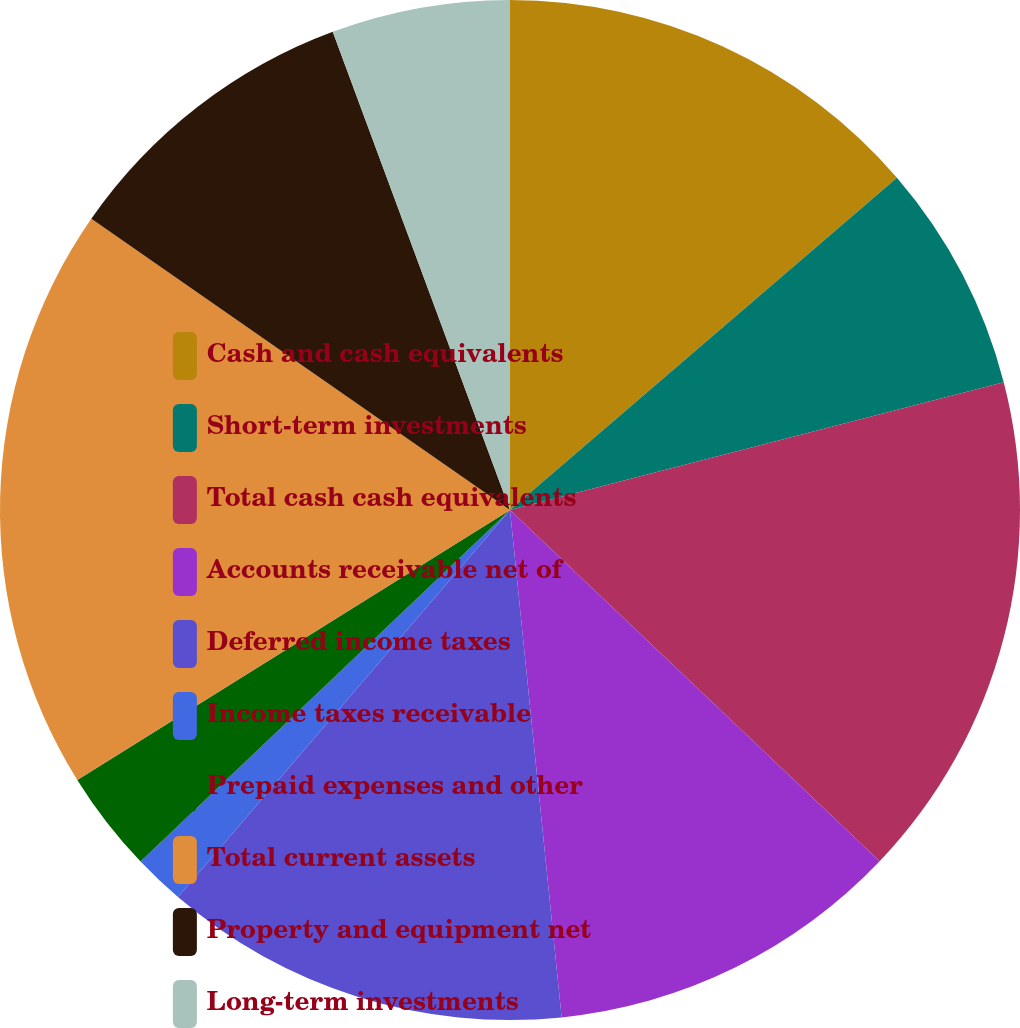<chart> <loc_0><loc_0><loc_500><loc_500><pie_chart><fcel>Cash and cash equivalents<fcel>Short-term investments<fcel>Total cash cash equivalents<fcel>Accounts receivable net of<fcel>Deferred income taxes<fcel>Income taxes receivable<fcel>Prepaid expenses and other<fcel>Total current assets<fcel>Property and equipment net<fcel>Long-term investments<nl><fcel>13.71%<fcel>7.26%<fcel>16.13%<fcel>11.29%<fcel>12.9%<fcel>1.61%<fcel>3.23%<fcel>18.55%<fcel>9.68%<fcel>5.65%<nl></chart> 